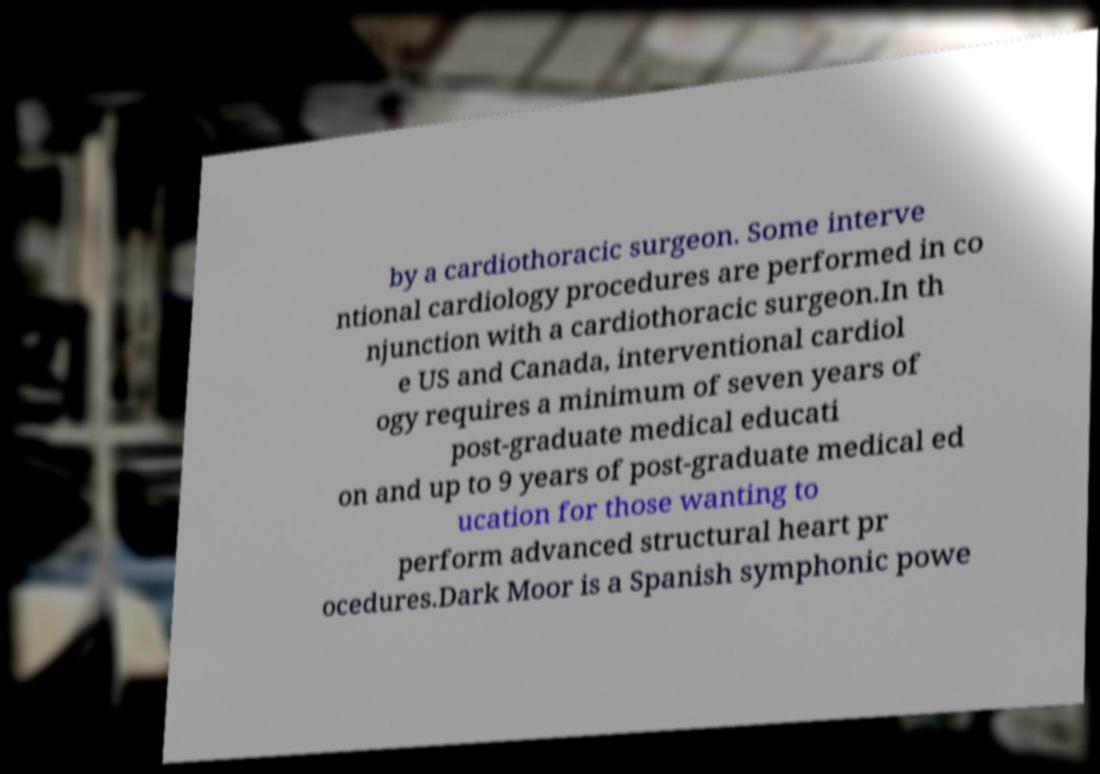Can you read and provide the text displayed in the image?This photo seems to have some interesting text. Can you extract and type it out for me? by a cardiothoracic surgeon. Some interve ntional cardiology procedures are performed in co njunction with a cardiothoracic surgeon.In th e US and Canada, interventional cardiol ogy requires a minimum of seven years of post-graduate medical educati on and up to 9 years of post-graduate medical ed ucation for those wanting to perform advanced structural heart pr ocedures.Dark Moor is a Spanish symphonic powe 